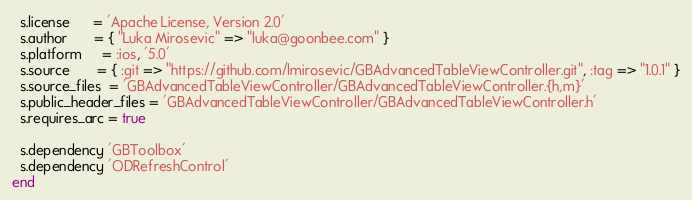Convert code to text. <code><loc_0><loc_0><loc_500><loc_500><_Ruby_>  s.license      = 'Apache License, Version 2.0'
  s.author       = { "Luka Mirosevic" => "luka@goonbee.com" }
  s.platform     = :ios, '5.0'
  s.source       = { :git => "https://github.com/lmirosevic/GBAdvancedTableViewController.git", :tag => "1.0.1" }
  s.source_files  = 'GBAdvancedTableViewController/GBAdvancedTableViewController.{h,m}'
  s.public_header_files = 'GBAdvancedTableViewController/GBAdvancedTableViewController.h'
  s.requires_arc = true

  s.dependency 'GBToolbox'
  s.dependency 'ODRefreshControl'
end
</code> 